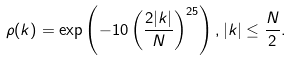Convert formula to latex. <formula><loc_0><loc_0><loc_500><loc_500>\rho ( k ) = \exp \left ( - 1 0 \left ( \frac { 2 | k | } { N } \right ) ^ { 2 5 } \right ) , | k | \leq \frac { N } { 2 } .</formula> 